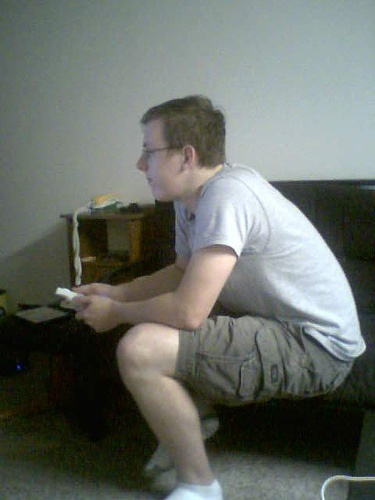Describe the objects in this image and their specific colors. I can see people in gray, lightgray, darkgray, and black tones, couch in gray, black, and purple tones, and remote in gray, lightgray, and darkgray tones in this image. 